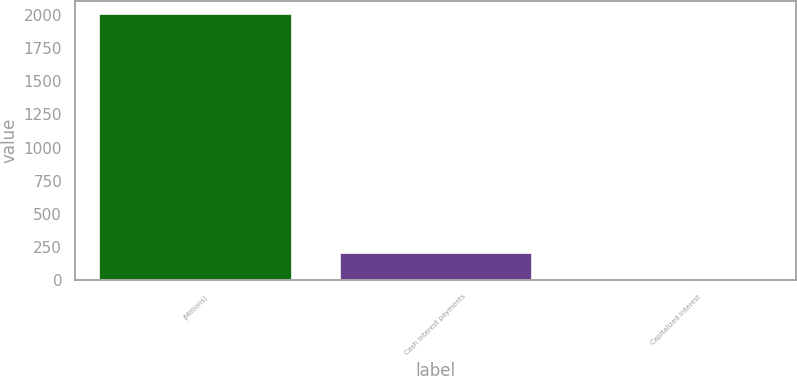Convert chart to OTSL. <chart><loc_0><loc_0><loc_500><loc_500><bar_chart><fcel>(Millions)<fcel>Cash interest payments<fcel>Capitalized interest<nl><fcel>2003<fcel>208.4<fcel>9<nl></chart> 